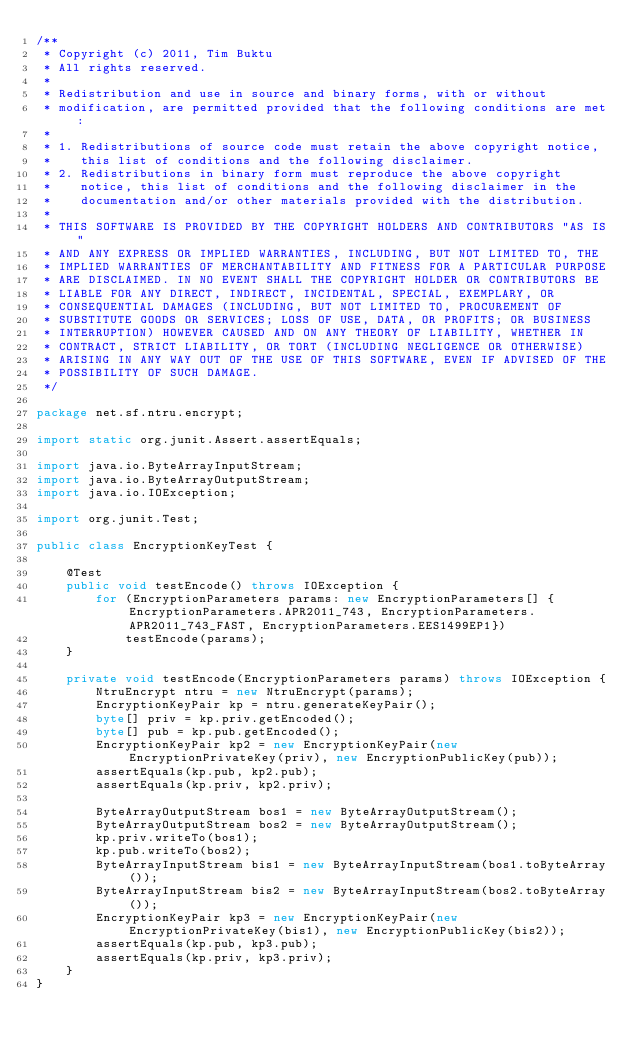<code> <loc_0><loc_0><loc_500><loc_500><_Java_>/**
 * Copyright (c) 2011, Tim Buktu
 * All rights reserved.
 *
 * Redistribution and use in source and binary forms, with or without
 * modification, are permitted provided that the following conditions are met:
 *
 * 1. Redistributions of source code must retain the above copyright notice,
 *    this list of conditions and the following disclaimer.
 * 2. Redistributions in binary form must reproduce the above copyright
 *    notice, this list of conditions and the following disclaimer in the
 *    documentation and/or other materials provided with the distribution.
 *
 * THIS SOFTWARE IS PROVIDED BY THE COPYRIGHT HOLDERS AND CONTRIBUTORS "AS IS"
 * AND ANY EXPRESS OR IMPLIED WARRANTIES, INCLUDING, BUT NOT LIMITED TO, THE
 * IMPLIED WARRANTIES OF MERCHANTABILITY AND FITNESS FOR A PARTICULAR PURPOSE
 * ARE DISCLAIMED. IN NO EVENT SHALL THE COPYRIGHT HOLDER OR CONTRIBUTORS BE
 * LIABLE FOR ANY DIRECT, INDIRECT, INCIDENTAL, SPECIAL, EXEMPLARY, OR
 * CONSEQUENTIAL DAMAGES (INCLUDING, BUT NOT LIMITED TO, PROCUREMENT OF
 * SUBSTITUTE GOODS OR SERVICES; LOSS OF USE, DATA, OR PROFITS; OR BUSINESS
 * INTERRUPTION) HOWEVER CAUSED AND ON ANY THEORY OF LIABILITY, WHETHER IN
 * CONTRACT, STRICT LIABILITY, OR TORT (INCLUDING NEGLIGENCE OR OTHERWISE)
 * ARISING IN ANY WAY OUT OF THE USE OF THIS SOFTWARE, EVEN IF ADVISED OF THE
 * POSSIBILITY OF SUCH DAMAGE.
 */

package net.sf.ntru.encrypt;

import static org.junit.Assert.assertEquals;

import java.io.ByteArrayInputStream;
import java.io.ByteArrayOutputStream;
import java.io.IOException;

import org.junit.Test;

public class EncryptionKeyTest {
    
    @Test
    public void testEncode() throws IOException {
        for (EncryptionParameters params: new EncryptionParameters[] {EncryptionParameters.APR2011_743, EncryptionParameters.APR2011_743_FAST, EncryptionParameters.EES1499EP1})
            testEncode(params);
    }
    
    private void testEncode(EncryptionParameters params) throws IOException {
        NtruEncrypt ntru = new NtruEncrypt(params);
        EncryptionKeyPair kp = ntru.generateKeyPair();
        byte[] priv = kp.priv.getEncoded();
        byte[] pub = kp.pub.getEncoded();
        EncryptionKeyPair kp2 = new EncryptionKeyPair(new EncryptionPrivateKey(priv), new EncryptionPublicKey(pub));
        assertEquals(kp.pub, kp2.pub);
        assertEquals(kp.priv, kp2.priv);
        
        ByteArrayOutputStream bos1 = new ByteArrayOutputStream();
        ByteArrayOutputStream bos2 = new ByteArrayOutputStream();
        kp.priv.writeTo(bos1);
        kp.pub.writeTo(bos2);
        ByteArrayInputStream bis1 = new ByteArrayInputStream(bos1.toByteArray());
        ByteArrayInputStream bis2 = new ByteArrayInputStream(bos2.toByteArray());
        EncryptionKeyPair kp3 = new EncryptionKeyPair(new EncryptionPrivateKey(bis1), new EncryptionPublicKey(bis2));
        assertEquals(kp.pub, kp3.pub);
        assertEquals(kp.priv, kp3.priv);
    }
}</code> 